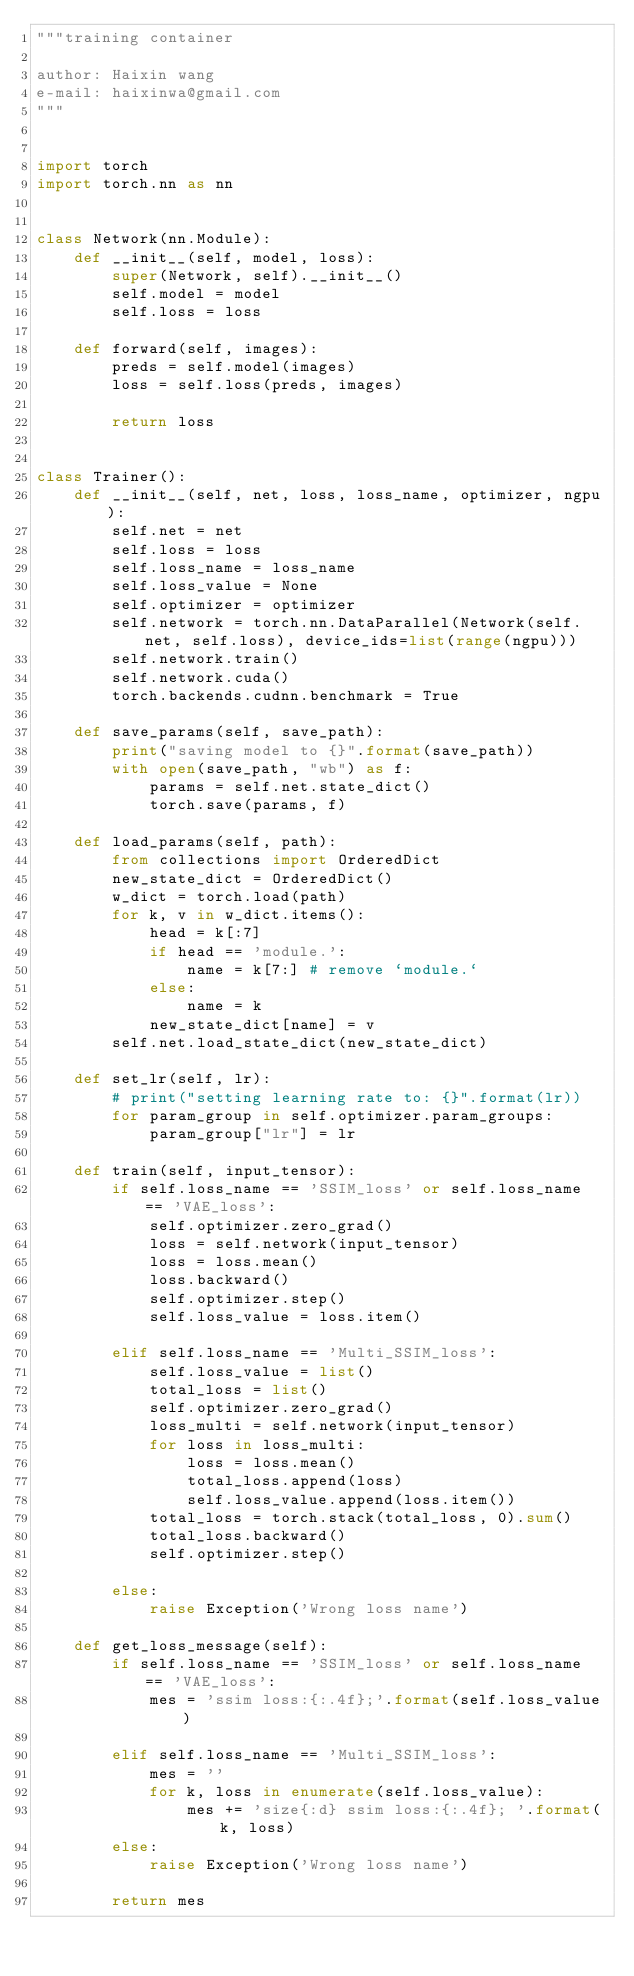Convert code to text. <code><loc_0><loc_0><loc_500><loc_500><_Python_>"""training container

author: Haixin wang
e-mail: haixinwa@gmail.com
"""


import torch
import torch.nn as nn


class Network(nn.Module):
    def __init__(self, model, loss):
        super(Network, self).__init__()
        self.model = model
        self.loss = loss

    def forward(self, images):
        preds = self.model(images)
        loss = self.loss(preds, images)

        return loss


class Trainer():
    def __init__(self, net, loss, loss_name, optimizer, ngpu):
        self.net = net
        self.loss = loss
        self.loss_name = loss_name
        self.loss_value = None
        self.optimizer = optimizer
        self.network = torch.nn.DataParallel(Network(self.net, self.loss), device_ids=list(range(ngpu)))
        self.network.train()
        self.network.cuda()
        torch.backends.cudnn.benchmark = True

    def save_params(self, save_path):
        print("saving model to {}".format(save_path))
        with open(save_path, "wb") as f:
            params = self.net.state_dict()
            torch.save(params, f)

    def load_params(self, path):
        from collections import OrderedDict
        new_state_dict = OrderedDict()
        w_dict = torch.load(path)
        for k, v in w_dict.items():
            head = k[:7]
            if head == 'module.':
                name = k[7:] # remove `module.`
            else:
                name = k
            new_state_dict[name] = v
        self.net.load_state_dict(new_state_dict)

    def set_lr(self, lr):
        # print("setting learning rate to: {}".format(lr))
        for param_group in self.optimizer.param_groups:
            param_group["lr"] = lr

    def train(self, input_tensor):
        if self.loss_name == 'SSIM_loss' or self.loss_name == 'VAE_loss':
            self.optimizer.zero_grad()
            loss = self.network(input_tensor)
            loss = loss.mean()
            loss.backward()
            self.optimizer.step()
            self.loss_value = loss.item()

        elif self.loss_name == 'Multi_SSIM_loss':
            self.loss_value = list()
            total_loss = list()
            self.optimizer.zero_grad()
            loss_multi = self.network(input_tensor)
            for loss in loss_multi:
                loss = loss.mean()
                total_loss.append(loss)
                self.loss_value.append(loss.item())
            total_loss = torch.stack(total_loss, 0).sum()
            total_loss.backward()
            self.optimizer.step()

        else:
            raise Exception('Wrong loss name')

    def get_loss_message(self):
        if self.loss_name == 'SSIM_loss' or self.loss_name == 'VAE_loss':
            mes = 'ssim loss:{:.4f};'.format(self.loss_value)

        elif self.loss_name == 'Multi_SSIM_loss':
            mes = ''
            for k, loss in enumerate(self.loss_value):
                mes += 'size{:d} ssim loss:{:.4f}; '.format(k, loss)
        else:
            raise Exception('Wrong loss name')

        return mes</code> 